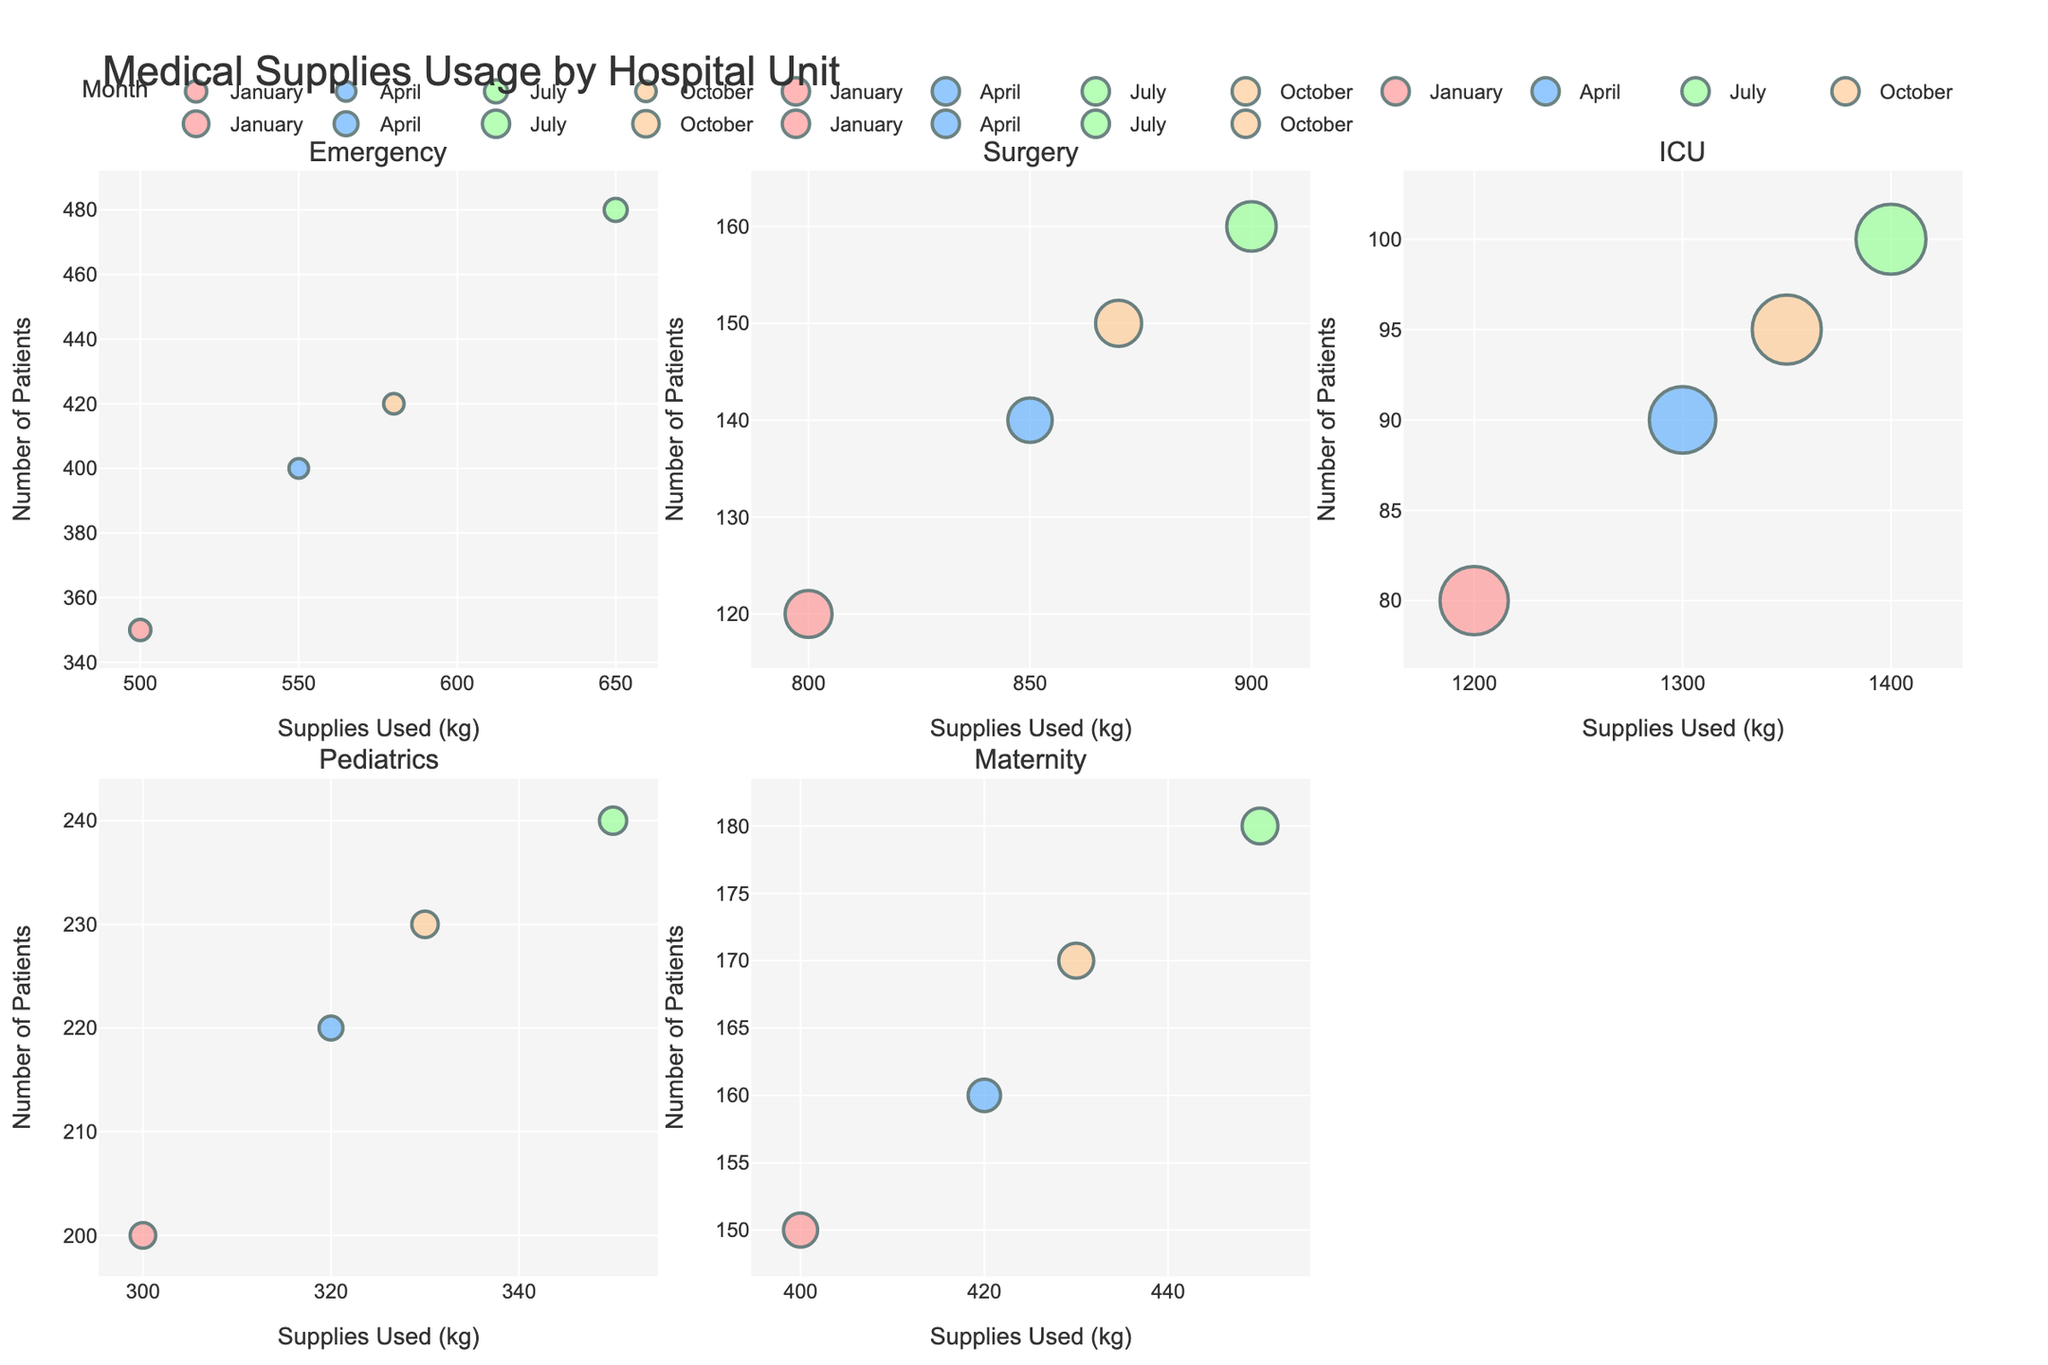Which unit uses the most medical supplies in July? We need to look at July for each unit's bubble on the x-axis (Supplies Used). Among the units (Emergency, Surgery, ICU, Pediatrics, and Maternity), ICU has the highest x-axis value in July.
Answer: ICU Which unit treats the most patients on average across all months? Look at the bubbles' y-axis (Number of Patients) across all months for each unit. We then average the values of y-axis per unit and compare them.
Answer: Emergency Which unit has the highest average stay in April? Look at the bubbles' sizes (representing the Average Stay) for April across all units. The Surgery unit has the largest bubble size in April.
Answer: Surgery By how much does the supplies usage in ICU increase from January to July? Identify the Supplies Used (x-axis) in ICU for January and July. Subtract January's value from July's value: 1400 - 1200.
Answer: 200 kg Which unit shows the least variation in the number of patients treated across different months? Look at the y-axis for each unit and find the one with the least difference between the highest and lowest values. Pediatrics has the least variation (200-240 patients).
Answer: Pediatrics Which month has the highest supplies usage across all units? Identify the bubbles with the highest x-axis values for each unit and check the corresponding months. All large values correspond to July.
Answer: July What is the average stay duration for ICU across all months? Sum the Average Stay values for ICU (8.0, 7.8, 8.2, 8.1) and divide by the number of months (4): (8.0 + 7.8 + 8.2 + 8.1) / 4.
Answer: 8.0 days Is there any unit where supplies usage consistently decreases over the months? Check the x-axis values for each unit month by month. Maternity shows a slight decrease from July (450) to October (430).
Answer: Yes, Maternity from July to October 